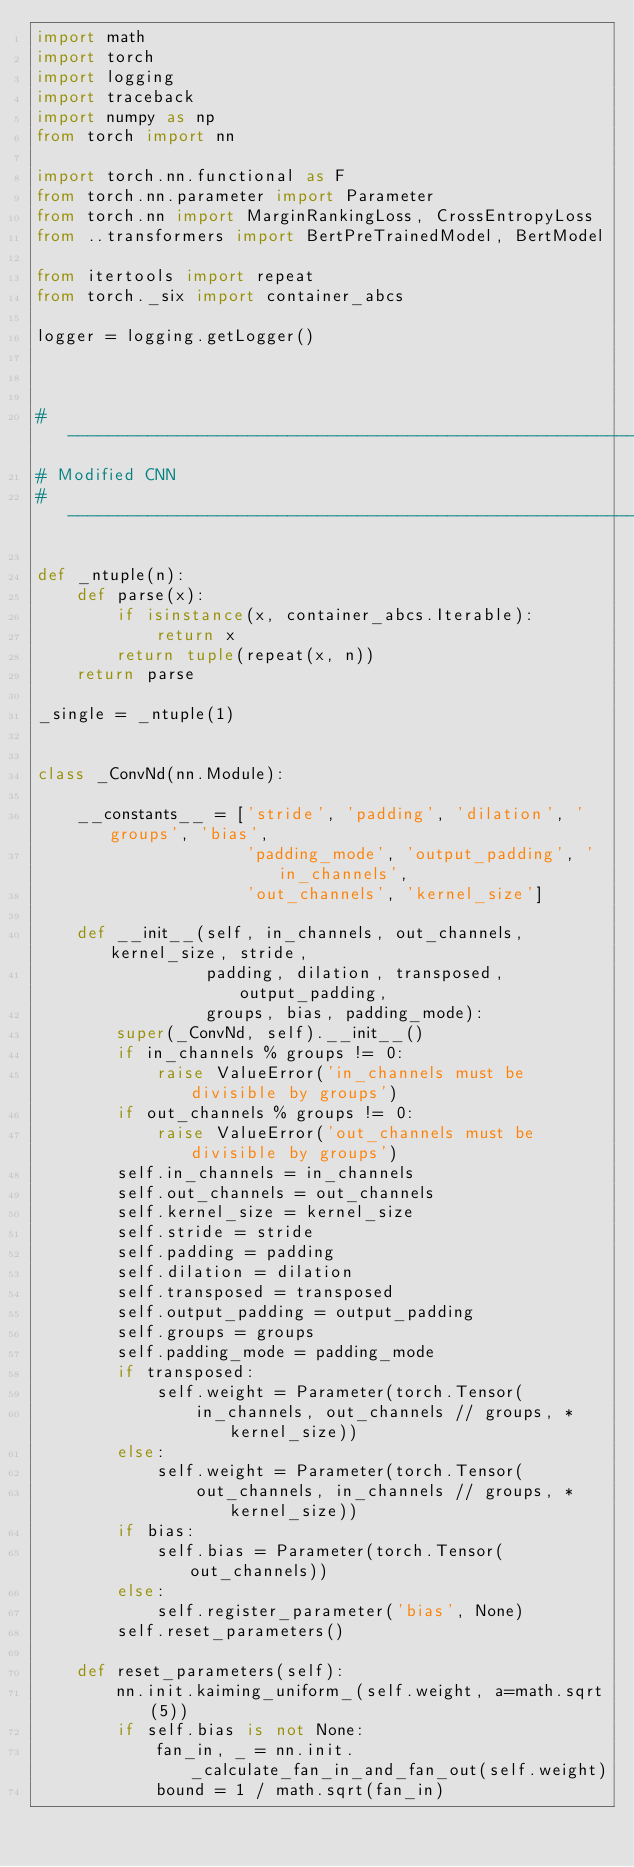Convert code to text. <code><loc_0><loc_0><loc_500><loc_500><_Python_>import math
import torch
import logging
import traceback
import numpy as np
from torch import nn

import torch.nn.functional as F
from torch.nn.parameter import Parameter
from torch.nn import MarginRankingLoss, CrossEntropyLoss
from ..transformers import BertPreTrainedModel, BertModel

from itertools import repeat
from torch._six import container_abcs

logger = logging.getLogger()



# -------------------------------------------------------------------------------------------
# Modified CNN 
# -------------------------------------------------------------------------------------------

def _ntuple(n):
    def parse(x):
        if isinstance(x, container_abcs.Iterable):
            return x
        return tuple(repeat(x, n))
    return parse

_single = _ntuple(1)


class _ConvNd(nn.Module):

    __constants__ = ['stride', 'padding', 'dilation', 'groups', 'bias',
                     'padding_mode', 'output_padding', 'in_channels',
                     'out_channels', 'kernel_size']

    def __init__(self, in_channels, out_channels, kernel_size, stride,
                 padding, dilation, transposed, output_padding,
                 groups, bias, padding_mode):
        super(_ConvNd, self).__init__()
        if in_channels % groups != 0:
            raise ValueError('in_channels must be divisible by groups')
        if out_channels % groups != 0:
            raise ValueError('out_channels must be divisible by groups')
        self.in_channels = in_channels
        self.out_channels = out_channels
        self.kernel_size = kernel_size
        self.stride = stride
        self.padding = padding
        self.dilation = dilation
        self.transposed = transposed
        self.output_padding = output_padding
        self.groups = groups
        self.padding_mode = padding_mode
        if transposed:
            self.weight = Parameter(torch.Tensor(
                in_channels, out_channels // groups, *kernel_size))
        else:
            self.weight = Parameter(torch.Tensor(
                out_channels, in_channels // groups, *kernel_size))
        if bias:
            self.bias = Parameter(torch.Tensor(out_channels))
        else:
            self.register_parameter('bias', None)
        self.reset_parameters()

    def reset_parameters(self):
        nn.init.kaiming_uniform_(self.weight, a=math.sqrt(5))
        if self.bias is not None:
            fan_in, _ = nn.init._calculate_fan_in_and_fan_out(self.weight)
            bound = 1 / math.sqrt(fan_in)</code> 